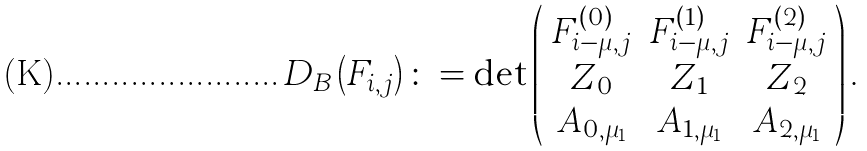Convert formula to latex. <formula><loc_0><loc_0><loc_500><loc_500>D _ { B } \left ( F _ { i , j } \right ) \colon = \det \left ( \begin{array} { c c c } F ^ { ( 0 ) } _ { i - \mu , j } & F ^ { ( 1 ) } _ { i - \mu , j } & F ^ { ( 2 ) } _ { i - \mu , j } \\ Z _ { 0 } & Z _ { 1 } & Z _ { 2 } \\ A _ { 0 , \mu _ { 1 } } & A _ { 1 , \mu _ { 1 } } & A _ { 2 , \mu _ { 1 } } \end{array} \right ) .</formula> 